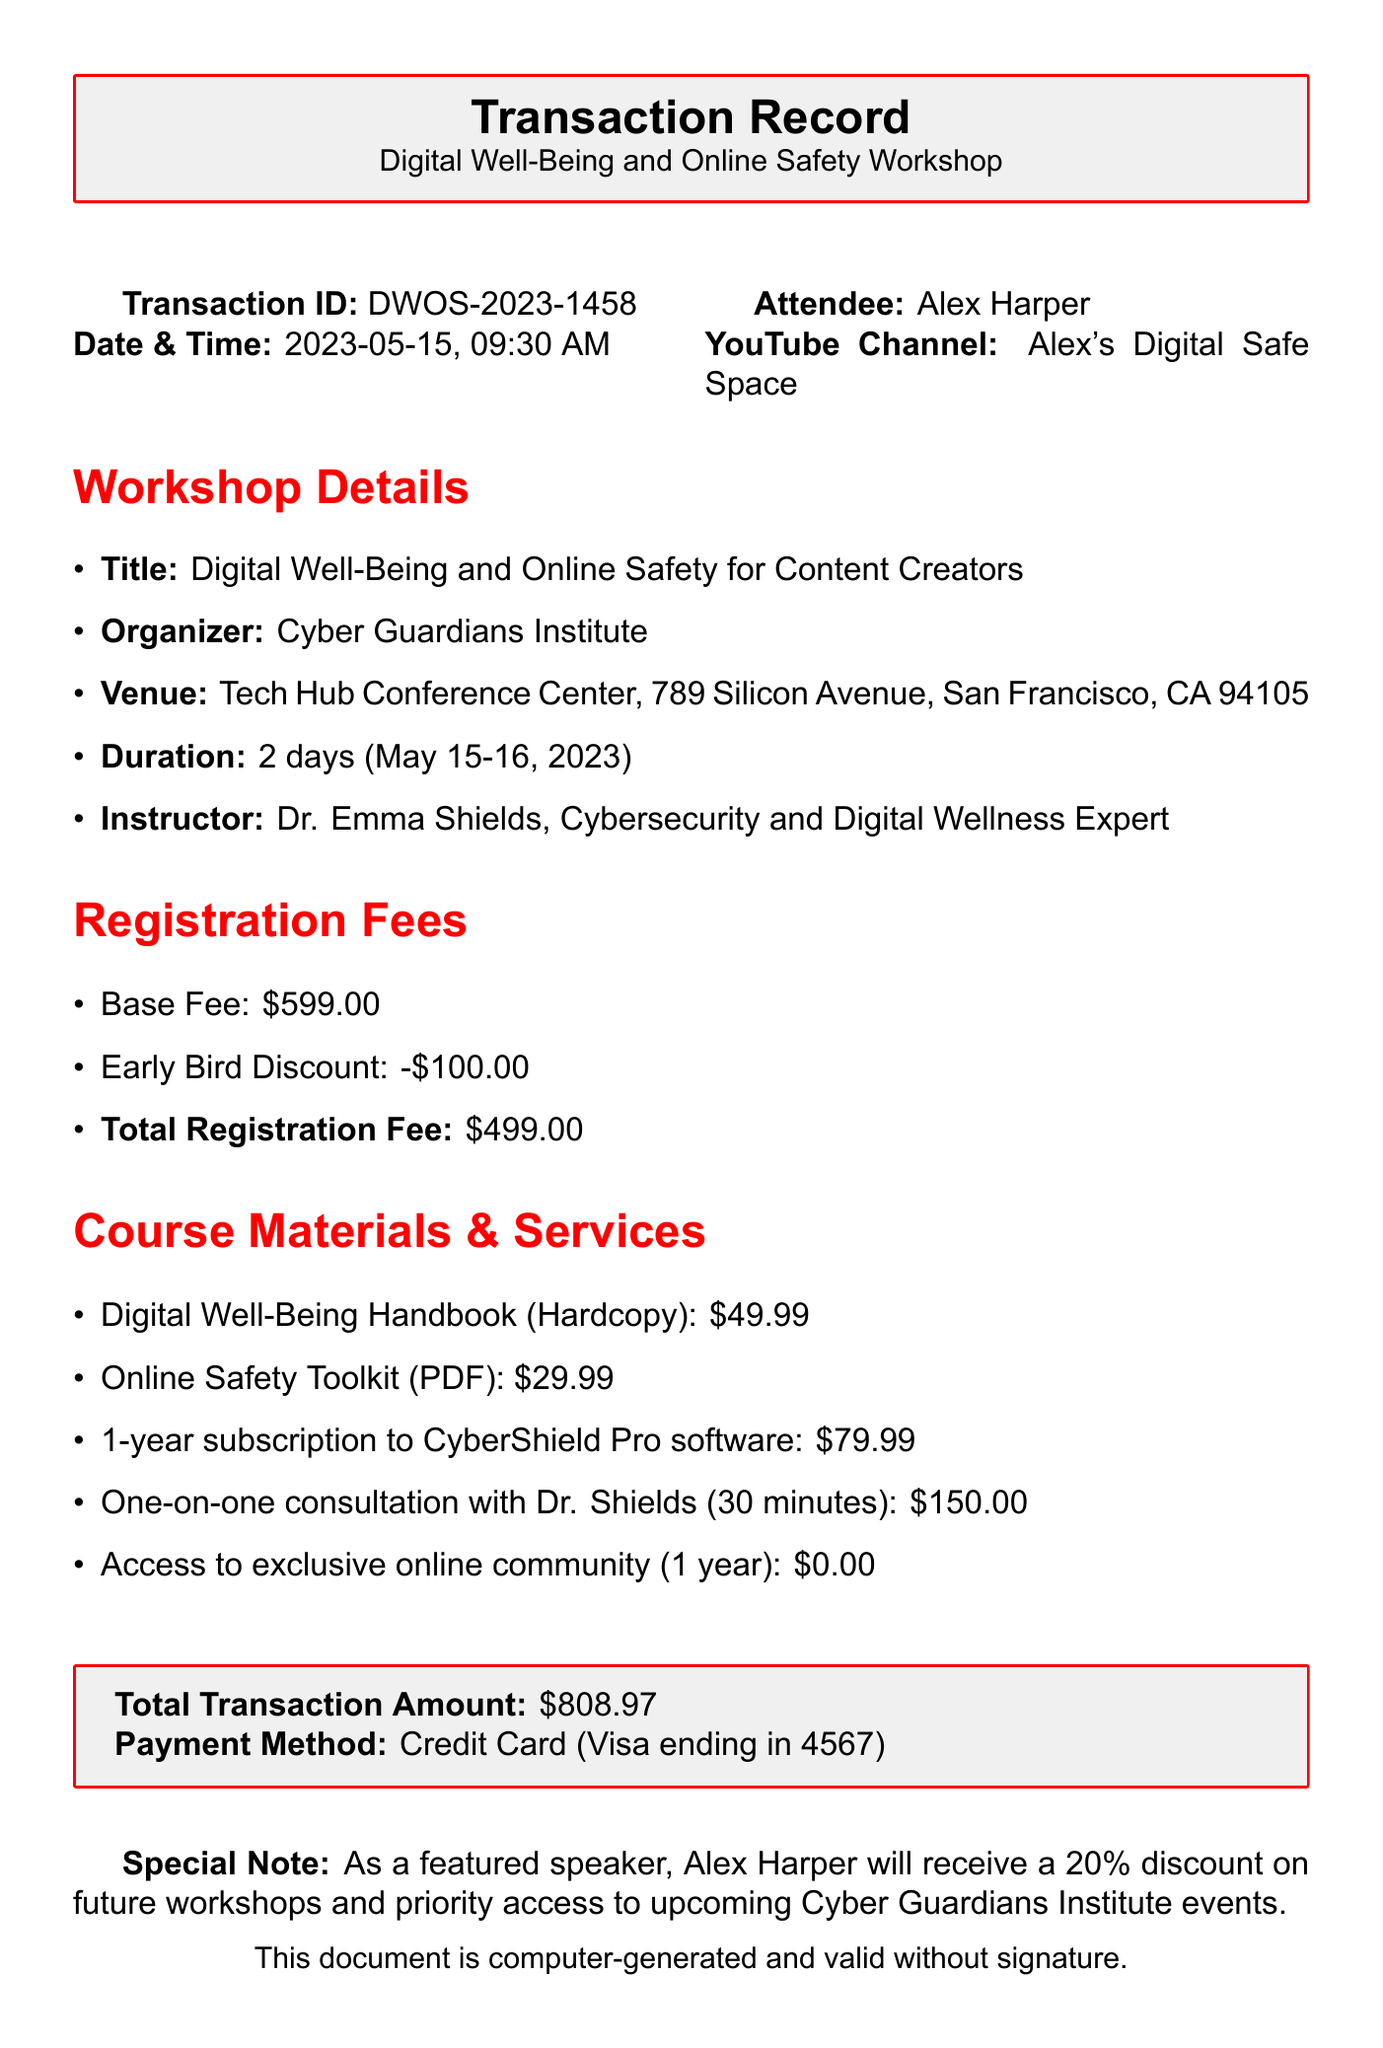What is the transaction ID? The transaction ID is a unique identifier for this particular transaction, which is listed in the document.
Answer: DWOS-2023-1458 What is the total registration fee? The total registration fee is the amount that the attendee needs to pay after any discounts are applied, which is specified in the fees section.
Answer: $499.00 Who is the instructor for the workshop? The instructor's name is mentioned in the workshop details, providing credibility and expertise for the event.
Answer: Dr. Emma Shields What is the duration of the workshop? The duration specifies how long the workshop takes place, detailed in the workshop information section.
Answer: 2 days (May 15-16, 2023) What is included in the course materials? The course materials section lists specific items provided for the workshop attendees, indicating what resources they will receive.
Answer: Digital Well-Being Handbook, Online Safety Toolkit, 1-year subscription to CyberShield Pro software What is the price for a one-on-one consultation? The price for additional services is specifically stated, providing options for more personalized support during the workshop.
Answer: $150.00 What is the total transaction amount? This is the final amount that the attendee pays, including registration fees and course materials, summarized for clarity.
Answer: $808.97 What special note is mentioned about the attendee? The special note highlights any additional perks or discounts that the attendee receives from their participation.
Answer: 20% discount on future workshops and priority access to events 